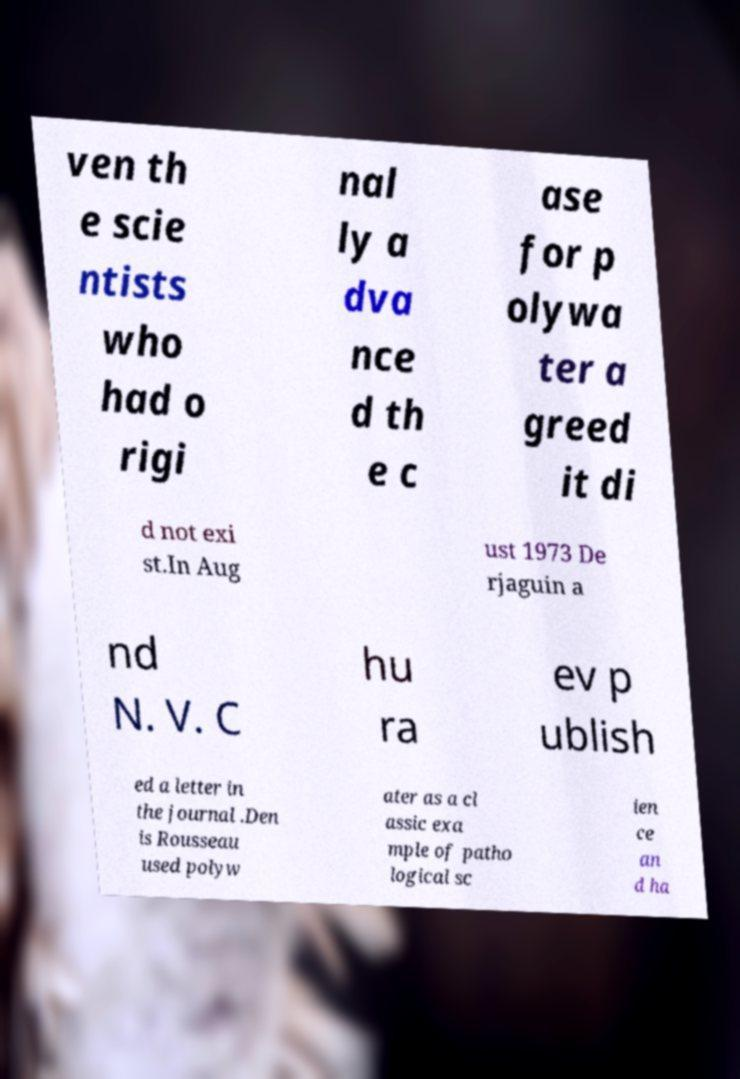Can you accurately transcribe the text from the provided image for me? ven th e scie ntists who had o rigi nal ly a dva nce d th e c ase for p olywa ter a greed it di d not exi st.In Aug ust 1973 De rjaguin a nd N. V. C hu ra ev p ublish ed a letter in the journal .Den is Rousseau used polyw ater as a cl assic exa mple of patho logical sc ien ce an d ha 